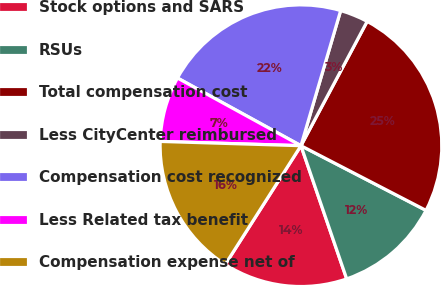Convert chart. <chart><loc_0><loc_0><loc_500><loc_500><pie_chart><fcel>Stock options and SARS<fcel>RSUs<fcel>Total compensation cost<fcel>Less CityCenter reimbursed<fcel>Compensation cost recognized<fcel>Less Related tax benefit<fcel>Compensation expense net of<nl><fcel>14.3%<fcel>12.14%<fcel>24.81%<fcel>3.24%<fcel>21.57%<fcel>7.5%<fcel>16.45%<nl></chart> 